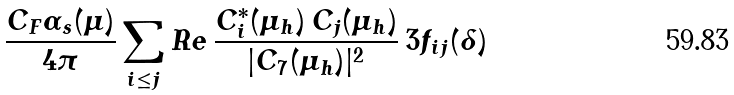Convert formula to latex. <formula><loc_0><loc_0><loc_500><loc_500>\frac { C _ { F } \alpha _ { s } ( \mu ) } { 4 \pi } \sum _ { i \leq j } R e \, \frac { C _ { i } ^ { * } ( \mu _ { h } ) \, C _ { j } ( \mu _ { h } ) } { | C _ { 7 } ( \mu _ { h } ) | ^ { 2 } } \, 3 f _ { i j } ( \delta )</formula> 